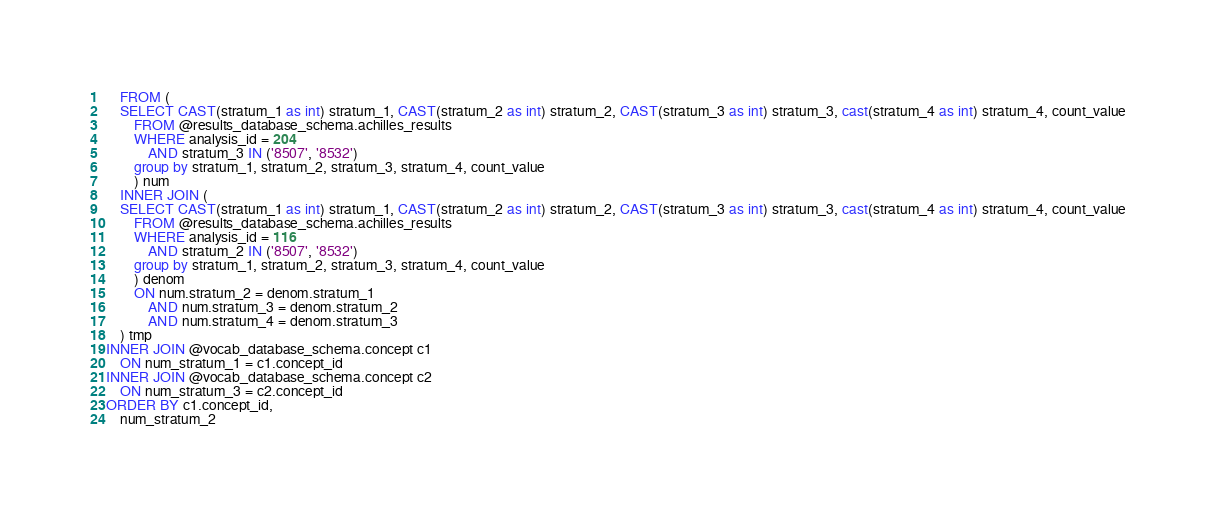Convert code to text. <code><loc_0><loc_0><loc_500><loc_500><_SQL_>	FROM (
    SELECT CAST(stratum_1 as int) stratum_1, CAST(stratum_2 as int) stratum_2, CAST(stratum_3 as int) stratum_3, cast(stratum_4 as int) stratum_4, count_value
		FROM @results_database_schema.achilles_results
		WHERE analysis_id = 204
			AND stratum_3 IN ('8507', '8532')
		group by stratum_1, stratum_2, stratum_3, stratum_4, count_value
		) num
	INNER JOIN (
    SELECT CAST(stratum_1 as int) stratum_1, CAST(stratum_2 as int) stratum_2, CAST(stratum_3 as int) stratum_3, cast(stratum_4 as int) stratum_4, count_value
		FROM @results_database_schema.achilles_results
		WHERE analysis_id = 116
			AND stratum_2 IN ('8507', '8532')
		group by stratum_1, stratum_2, stratum_3, stratum_4, count_value
		) denom
		ON num.stratum_2 = denom.stratum_1
			AND num.stratum_3 = denom.stratum_2
			AND num.stratum_4 = denom.stratum_3
	) tmp
INNER JOIN @vocab_database_schema.concept c1
	ON num_stratum_1 = c1.concept_id
INNER JOIN @vocab_database_schema.concept c2
	ON num_stratum_3 = c2.concept_id
ORDER BY c1.concept_id,
	num_stratum_2
</code> 